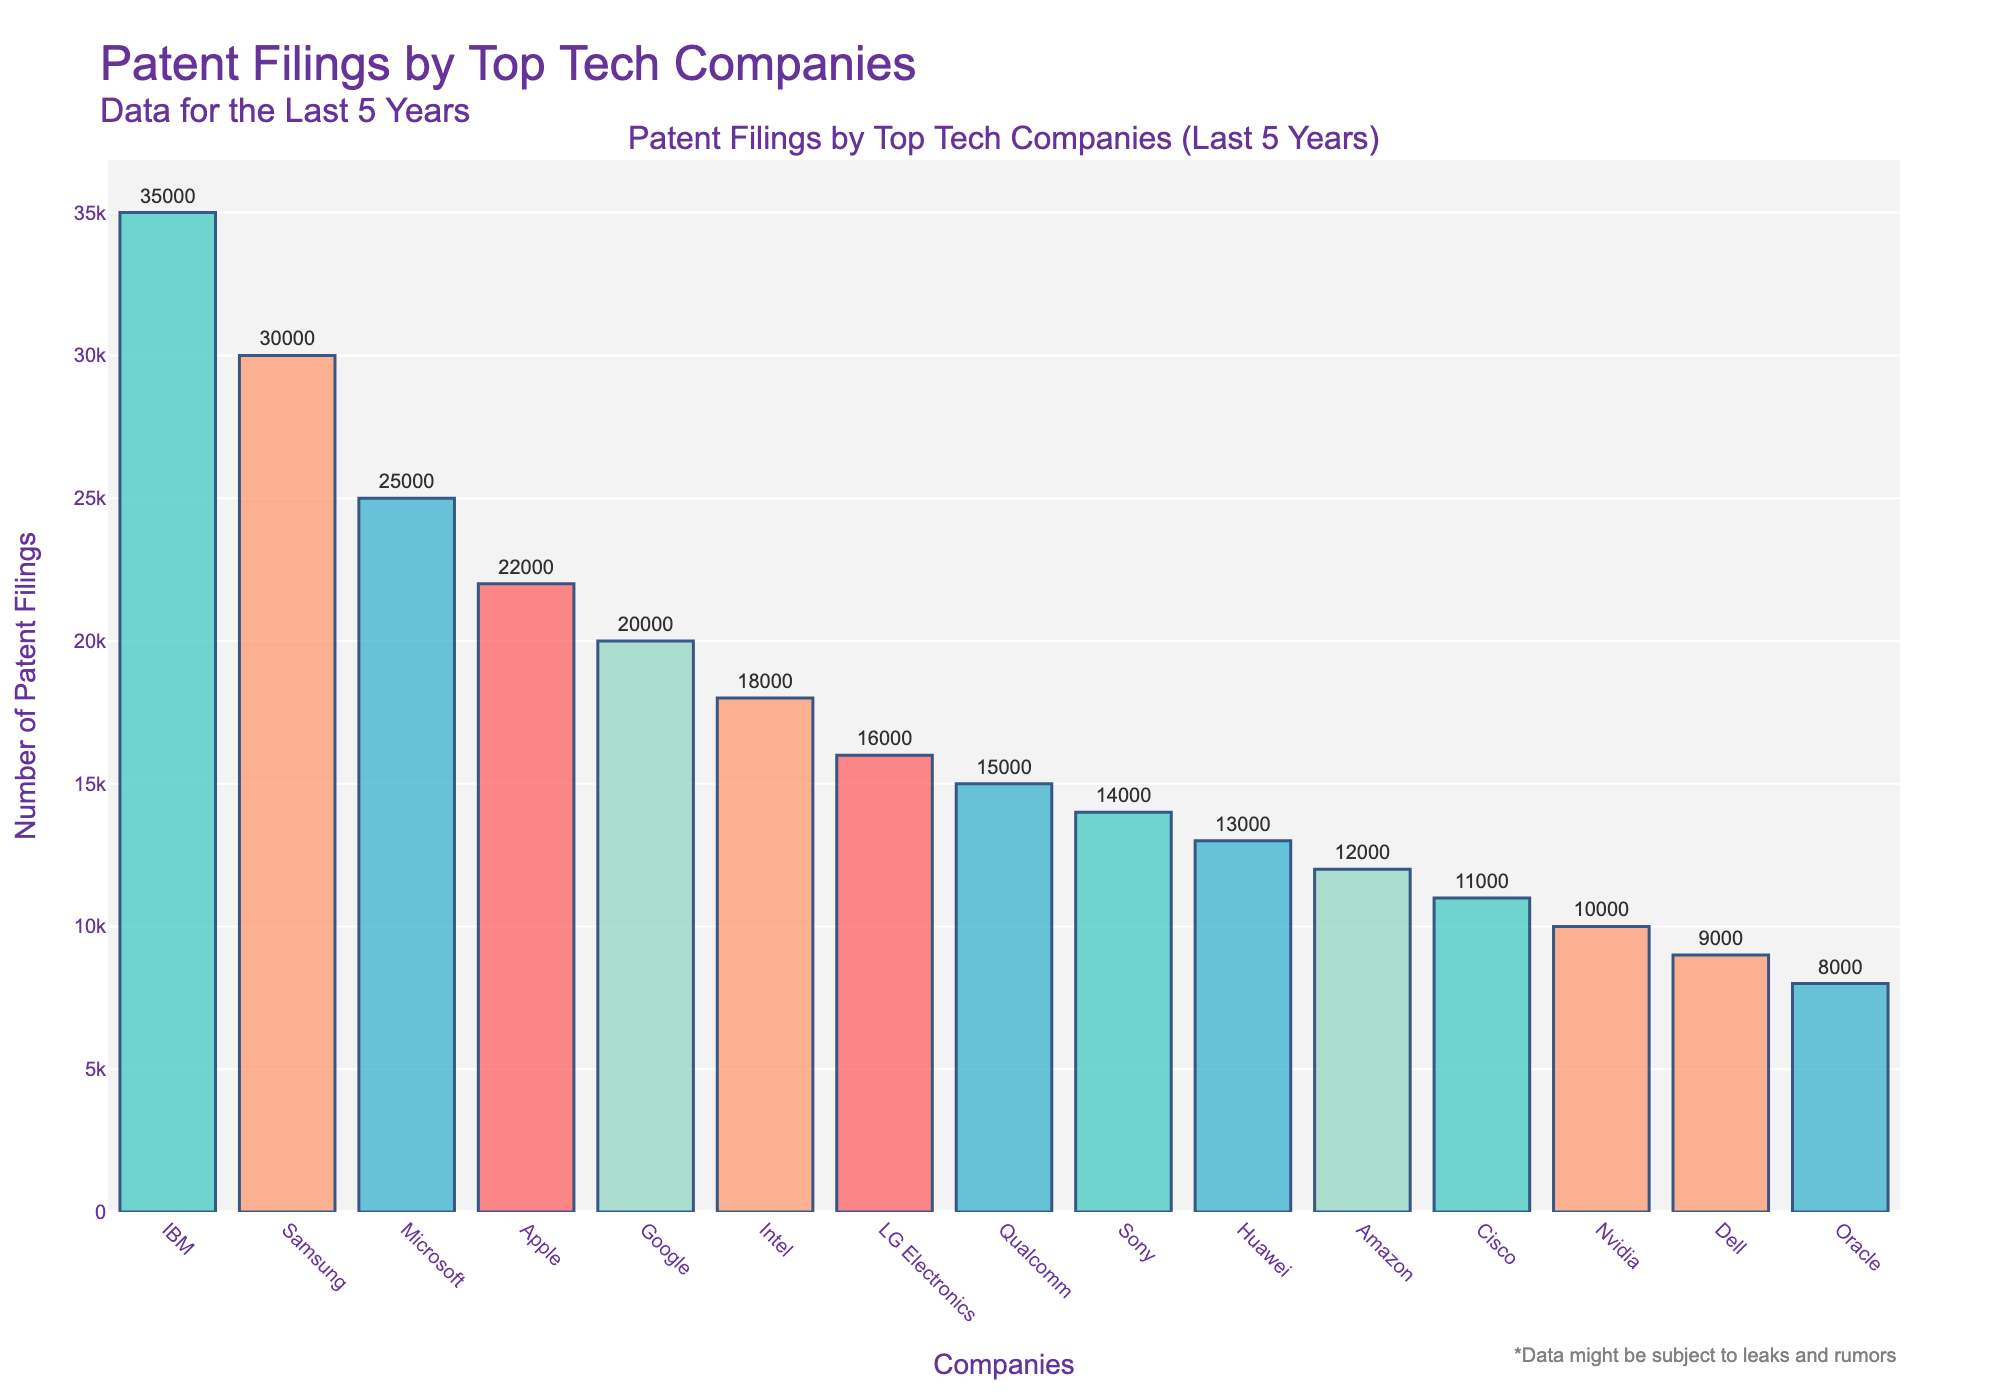What's the average number of patent filings for the top 5 companies? First, sum the number of patent filings for the top 5 companies: IBM (35000) + Samsung (30000) + Microsoft (25000) + Apple (22000) + Google (20000) = 132000. Then, divide by 5 to get the average: 132000 / 5 = 26400
Answer: 26400 Which company has the highest number of patent filings? By looking at the height of the bars, the company with the tallest bar is IBM, which has the highest number of patent filings.
Answer: IBM Is the number of patent filings by Google greater than that of Intel? From the figure, Google's patent filings are 20000, while Intel's are 18000. Since 20000 > 18000, Google has more filings than Intel.
Answer: Yes What is the total number of patent filings for Amazon, Cisco, and Nvidia combined? Add the number of patent filings for Amazon (12000), Cisco (11000), and Nvidia (10000): 12000 + 11000 + 10000 = 33000
Answer: 33000 How many companies have fewer than 15000 patent filings? From the data, the companies with fewer than 15000 patent filings are Sony (14000), Huawei (13000), Amazon (12000), Cisco (11000), Nvidia (10000), Dell (9000), and Oracle (8000). Count these companies: 7
Answer: 7 Among the companies listed, which one comes in third place in terms of the number of patent filings? The third tallest bar in the plot corresponds to Microsoft with 25000 patent filings.
Answer: Microsoft What's the difference in the number of patent filings between Apple and Qualcomm? Subtract Qualcomm’s number of filings (15000) from Apple's (22000): 22000 - 15000 = 7000
Answer: 7000 What is the median number of patent filings among the listed companies? To find the median, list the number of patent filings in ascending order and find the middle value: 8000, 9000, 10000, 11000, 12000, 13000, 14000, 15000, 16000, 18000, 20000, 22000, 25000, 30000, 35000. The middle value is 15000.
Answer: 15000 Which company's bar has a green color? By visually inspecting the colors of the bars, LG Electronics’ bar is green.
Answer: LG Electronics 